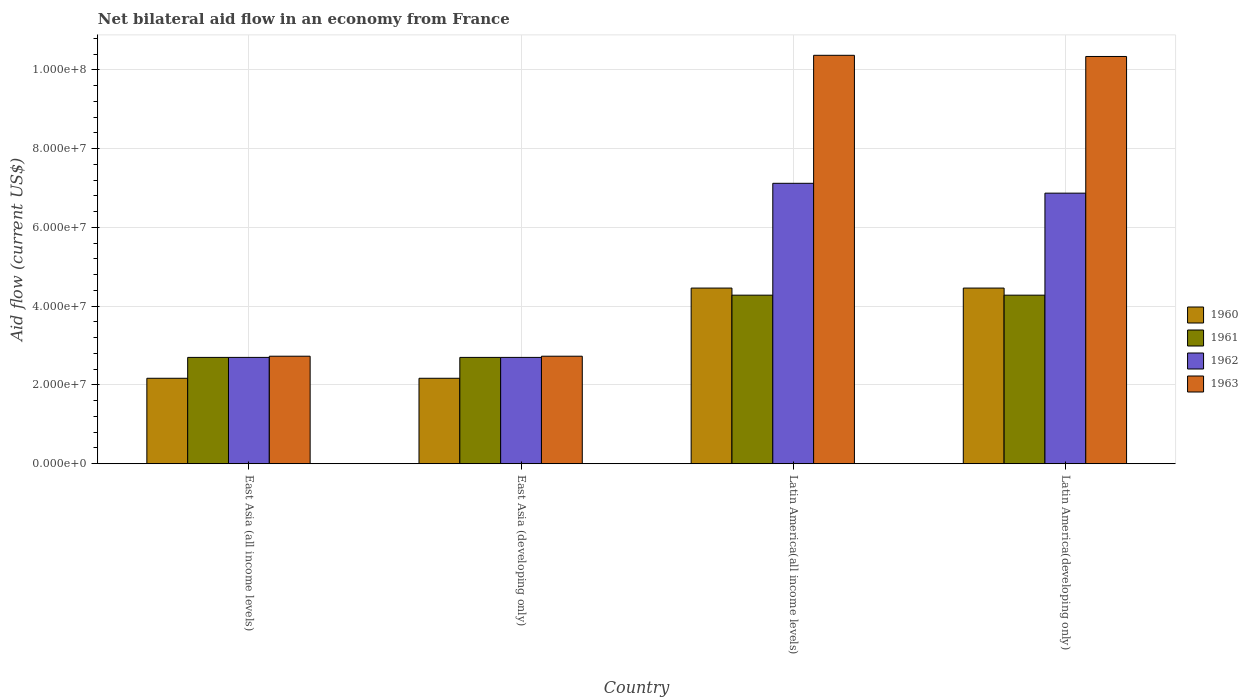Are the number of bars per tick equal to the number of legend labels?
Offer a terse response. Yes. How many bars are there on the 3rd tick from the left?
Your response must be concise. 4. How many bars are there on the 1st tick from the right?
Your response must be concise. 4. What is the label of the 3rd group of bars from the left?
Your answer should be compact. Latin America(all income levels). In how many cases, is the number of bars for a given country not equal to the number of legend labels?
Give a very brief answer. 0. What is the net bilateral aid flow in 1962 in Latin America(developing only)?
Offer a terse response. 6.87e+07. Across all countries, what is the maximum net bilateral aid flow in 1961?
Your answer should be very brief. 4.28e+07. Across all countries, what is the minimum net bilateral aid flow in 1961?
Offer a very short reply. 2.70e+07. In which country was the net bilateral aid flow in 1960 maximum?
Give a very brief answer. Latin America(all income levels). In which country was the net bilateral aid flow in 1963 minimum?
Offer a very short reply. East Asia (all income levels). What is the total net bilateral aid flow in 1962 in the graph?
Keep it short and to the point. 1.94e+08. What is the difference between the net bilateral aid flow in 1960 in East Asia (developing only) and that in Latin America(all income levels)?
Offer a very short reply. -2.29e+07. What is the difference between the net bilateral aid flow in 1963 in Latin America(all income levels) and the net bilateral aid flow in 1960 in Latin America(developing only)?
Offer a terse response. 5.91e+07. What is the average net bilateral aid flow in 1962 per country?
Provide a succinct answer. 4.85e+07. What is the difference between the net bilateral aid flow of/in 1961 and net bilateral aid flow of/in 1960 in Latin America(all income levels)?
Provide a succinct answer. -1.80e+06. What is the ratio of the net bilateral aid flow in 1963 in Latin America(all income levels) to that in Latin America(developing only)?
Your answer should be very brief. 1. What is the difference between the highest and the second highest net bilateral aid flow in 1960?
Your answer should be compact. 2.29e+07. What is the difference between the highest and the lowest net bilateral aid flow in 1963?
Make the answer very short. 7.64e+07. Is it the case that in every country, the sum of the net bilateral aid flow in 1960 and net bilateral aid flow in 1963 is greater than the sum of net bilateral aid flow in 1961 and net bilateral aid flow in 1962?
Make the answer very short. Yes. What does the 4th bar from the right in East Asia (developing only) represents?
Offer a terse response. 1960. Is it the case that in every country, the sum of the net bilateral aid flow in 1962 and net bilateral aid flow in 1960 is greater than the net bilateral aid flow in 1961?
Offer a terse response. Yes. How many bars are there?
Offer a terse response. 16. How many countries are there in the graph?
Your answer should be very brief. 4. Does the graph contain any zero values?
Provide a short and direct response. No. Does the graph contain grids?
Provide a short and direct response. Yes. How many legend labels are there?
Provide a succinct answer. 4. What is the title of the graph?
Your answer should be very brief. Net bilateral aid flow in an economy from France. What is the label or title of the Y-axis?
Ensure brevity in your answer.  Aid flow (current US$). What is the Aid flow (current US$) in 1960 in East Asia (all income levels)?
Your response must be concise. 2.17e+07. What is the Aid flow (current US$) in 1961 in East Asia (all income levels)?
Offer a very short reply. 2.70e+07. What is the Aid flow (current US$) of 1962 in East Asia (all income levels)?
Your answer should be compact. 2.70e+07. What is the Aid flow (current US$) of 1963 in East Asia (all income levels)?
Provide a succinct answer. 2.73e+07. What is the Aid flow (current US$) in 1960 in East Asia (developing only)?
Your answer should be very brief. 2.17e+07. What is the Aid flow (current US$) of 1961 in East Asia (developing only)?
Provide a succinct answer. 2.70e+07. What is the Aid flow (current US$) in 1962 in East Asia (developing only)?
Offer a terse response. 2.70e+07. What is the Aid flow (current US$) in 1963 in East Asia (developing only)?
Your answer should be very brief. 2.73e+07. What is the Aid flow (current US$) in 1960 in Latin America(all income levels)?
Provide a short and direct response. 4.46e+07. What is the Aid flow (current US$) of 1961 in Latin America(all income levels)?
Your response must be concise. 4.28e+07. What is the Aid flow (current US$) in 1962 in Latin America(all income levels)?
Your answer should be compact. 7.12e+07. What is the Aid flow (current US$) in 1963 in Latin America(all income levels)?
Your answer should be very brief. 1.04e+08. What is the Aid flow (current US$) in 1960 in Latin America(developing only)?
Keep it short and to the point. 4.46e+07. What is the Aid flow (current US$) in 1961 in Latin America(developing only)?
Provide a short and direct response. 4.28e+07. What is the Aid flow (current US$) of 1962 in Latin America(developing only)?
Provide a short and direct response. 6.87e+07. What is the Aid flow (current US$) of 1963 in Latin America(developing only)?
Your answer should be compact. 1.03e+08. Across all countries, what is the maximum Aid flow (current US$) in 1960?
Your response must be concise. 4.46e+07. Across all countries, what is the maximum Aid flow (current US$) in 1961?
Your answer should be compact. 4.28e+07. Across all countries, what is the maximum Aid flow (current US$) of 1962?
Give a very brief answer. 7.12e+07. Across all countries, what is the maximum Aid flow (current US$) in 1963?
Give a very brief answer. 1.04e+08. Across all countries, what is the minimum Aid flow (current US$) of 1960?
Provide a succinct answer. 2.17e+07. Across all countries, what is the minimum Aid flow (current US$) in 1961?
Your answer should be very brief. 2.70e+07. Across all countries, what is the minimum Aid flow (current US$) of 1962?
Make the answer very short. 2.70e+07. Across all countries, what is the minimum Aid flow (current US$) of 1963?
Offer a terse response. 2.73e+07. What is the total Aid flow (current US$) of 1960 in the graph?
Keep it short and to the point. 1.33e+08. What is the total Aid flow (current US$) in 1961 in the graph?
Give a very brief answer. 1.40e+08. What is the total Aid flow (current US$) in 1962 in the graph?
Offer a terse response. 1.94e+08. What is the total Aid flow (current US$) of 1963 in the graph?
Offer a terse response. 2.62e+08. What is the difference between the Aid flow (current US$) in 1960 in East Asia (all income levels) and that in East Asia (developing only)?
Your answer should be compact. 0. What is the difference between the Aid flow (current US$) in 1961 in East Asia (all income levels) and that in East Asia (developing only)?
Your response must be concise. 0. What is the difference between the Aid flow (current US$) in 1962 in East Asia (all income levels) and that in East Asia (developing only)?
Make the answer very short. 0. What is the difference between the Aid flow (current US$) of 1963 in East Asia (all income levels) and that in East Asia (developing only)?
Your answer should be very brief. 0. What is the difference between the Aid flow (current US$) in 1960 in East Asia (all income levels) and that in Latin America(all income levels)?
Provide a succinct answer. -2.29e+07. What is the difference between the Aid flow (current US$) of 1961 in East Asia (all income levels) and that in Latin America(all income levels)?
Make the answer very short. -1.58e+07. What is the difference between the Aid flow (current US$) of 1962 in East Asia (all income levels) and that in Latin America(all income levels)?
Offer a very short reply. -4.42e+07. What is the difference between the Aid flow (current US$) in 1963 in East Asia (all income levels) and that in Latin America(all income levels)?
Keep it short and to the point. -7.64e+07. What is the difference between the Aid flow (current US$) of 1960 in East Asia (all income levels) and that in Latin America(developing only)?
Offer a terse response. -2.29e+07. What is the difference between the Aid flow (current US$) of 1961 in East Asia (all income levels) and that in Latin America(developing only)?
Offer a very short reply. -1.58e+07. What is the difference between the Aid flow (current US$) in 1962 in East Asia (all income levels) and that in Latin America(developing only)?
Your answer should be very brief. -4.17e+07. What is the difference between the Aid flow (current US$) in 1963 in East Asia (all income levels) and that in Latin America(developing only)?
Ensure brevity in your answer.  -7.61e+07. What is the difference between the Aid flow (current US$) in 1960 in East Asia (developing only) and that in Latin America(all income levels)?
Offer a very short reply. -2.29e+07. What is the difference between the Aid flow (current US$) in 1961 in East Asia (developing only) and that in Latin America(all income levels)?
Ensure brevity in your answer.  -1.58e+07. What is the difference between the Aid flow (current US$) in 1962 in East Asia (developing only) and that in Latin America(all income levels)?
Provide a short and direct response. -4.42e+07. What is the difference between the Aid flow (current US$) in 1963 in East Asia (developing only) and that in Latin America(all income levels)?
Offer a very short reply. -7.64e+07. What is the difference between the Aid flow (current US$) in 1960 in East Asia (developing only) and that in Latin America(developing only)?
Offer a very short reply. -2.29e+07. What is the difference between the Aid flow (current US$) in 1961 in East Asia (developing only) and that in Latin America(developing only)?
Ensure brevity in your answer.  -1.58e+07. What is the difference between the Aid flow (current US$) in 1962 in East Asia (developing only) and that in Latin America(developing only)?
Give a very brief answer. -4.17e+07. What is the difference between the Aid flow (current US$) in 1963 in East Asia (developing only) and that in Latin America(developing only)?
Your answer should be compact. -7.61e+07. What is the difference between the Aid flow (current US$) of 1961 in Latin America(all income levels) and that in Latin America(developing only)?
Provide a succinct answer. 0. What is the difference between the Aid flow (current US$) in 1962 in Latin America(all income levels) and that in Latin America(developing only)?
Your answer should be very brief. 2.50e+06. What is the difference between the Aid flow (current US$) in 1963 in Latin America(all income levels) and that in Latin America(developing only)?
Your answer should be very brief. 3.00e+05. What is the difference between the Aid flow (current US$) of 1960 in East Asia (all income levels) and the Aid flow (current US$) of 1961 in East Asia (developing only)?
Your answer should be compact. -5.30e+06. What is the difference between the Aid flow (current US$) in 1960 in East Asia (all income levels) and the Aid flow (current US$) in 1962 in East Asia (developing only)?
Ensure brevity in your answer.  -5.30e+06. What is the difference between the Aid flow (current US$) of 1960 in East Asia (all income levels) and the Aid flow (current US$) of 1963 in East Asia (developing only)?
Offer a terse response. -5.60e+06. What is the difference between the Aid flow (current US$) of 1961 in East Asia (all income levels) and the Aid flow (current US$) of 1963 in East Asia (developing only)?
Your response must be concise. -3.00e+05. What is the difference between the Aid flow (current US$) in 1960 in East Asia (all income levels) and the Aid flow (current US$) in 1961 in Latin America(all income levels)?
Your answer should be very brief. -2.11e+07. What is the difference between the Aid flow (current US$) in 1960 in East Asia (all income levels) and the Aid flow (current US$) in 1962 in Latin America(all income levels)?
Provide a succinct answer. -4.95e+07. What is the difference between the Aid flow (current US$) in 1960 in East Asia (all income levels) and the Aid flow (current US$) in 1963 in Latin America(all income levels)?
Offer a very short reply. -8.20e+07. What is the difference between the Aid flow (current US$) of 1961 in East Asia (all income levels) and the Aid flow (current US$) of 1962 in Latin America(all income levels)?
Offer a terse response. -4.42e+07. What is the difference between the Aid flow (current US$) in 1961 in East Asia (all income levels) and the Aid flow (current US$) in 1963 in Latin America(all income levels)?
Ensure brevity in your answer.  -7.67e+07. What is the difference between the Aid flow (current US$) in 1962 in East Asia (all income levels) and the Aid flow (current US$) in 1963 in Latin America(all income levels)?
Your response must be concise. -7.67e+07. What is the difference between the Aid flow (current US$) in 1960 in East Asia (all income levels) and the Aid flow (current US$) in 1961 in Latin America(developing only)?
Your answer should be compact. -2.11e+07. What is the difference between the Aid flow (current US$) of 1960 in East Asia (all income levels) and the Aid flow (current US$) of 1962 in Latin America(developing only)?
Offer a terse response. -4.70e+07. What is the difference between the Aid flow (current US$) in 1960 in East Asia (all income levels) and the Aid flow (current US$) in 1963 in Latin America(developing only)?
Your answer should be compact. -8.17e+07. What is the difference between the Aid flow (current US$) of 1961 in East Asia (all income levels) and the Aid flow (current US$) of 1962 in Latin America(developing only)?
Offer a very short reply. -4.17e+07. What is the difference between the Aid flow (current US$) in 1961 in East Asia (all income levels) and the Aid flow (current US$) in 1963 in Latin America(developing only)?
Offer a very short reply. -7.64e+07. What is the difference between the Aid flow (current US$) in 1962 in East Asia (all income levels) and the Aid flow (current US$) in 1963 in Latin America(developing only)?
Offer a very short reply. -7.64e+07. What is the difference between the Aid flow (current US$) in 1960 in East Asia (developing only) and the Aid flow (current US$) in 1961 in Latin America(all income levels)?
Your response must be concise. -2.11e+07. What is the difference between the Aid flow (current US$) of 1960 in East Asia (developing only) and the Aid flow (current US$) of 1962 in Latin America(all income levels)?
Offer a very short reply. -4.95e+07. What is the difference between the Aid flow (current US$) in 1960 in East Asia (developing only) and the Aid flow (current US$) in 1963 in Latin America(all income levels)?
Give a very brief answer. -8.20e+07. What is the difference between the Aid flow (current US$) in 1961 in East Asia (developing only) and the Aid flow (current US$) in 1962 in Latin America(all income levels)?
Ensure brevity in your answer.  -4.42e+07. What is the difference between the Aid flow (current US$) of 1961 in East Asia (developing only) and the Aid flow (current US$) of 1963 in Latin America(all income levels)?
Provide a succinct answer. -7.67e+07. What is the difference between the Aid flow (current US$) in 1962 in East Asia (developing only) and the Aid flow (current US$) in 1963 in Latin America(all income levels)?
Keep it short and to the point. -7.67e+07. What is the difference between the Aid flow (current US$) in 1960 in East Asia (developing only) and the Aid flow (current US$) in 1961 in Latin America(developing only)?
Provide a short and direct response. -2.11e+07. What is the difference between the Aid flow (current US$) in 1960 in East Asia (developing only) and the Aid flow (current US$) in 1962 in Latin America(developing only)?
Keep it short and to the point. -4.70e+07. What is the difference between the Aid flow (current US$) of 1960 in East Asia (developing only) and the Aid flow (current US$) of 1963 in Latin America(developing only)?
Give a very brief answer. -8.17e+07. What is the difference between the Aid flow (current US$) in 1961 in East Asia (developing only) and the Aid flow (current US$) in 1962 in Latin America(developing only)?
Give a very brief answer. -4.17e+07. What is the difference between the Aid flow (current US$) in 1961 in East Asia (developing only) and the Aid flow (current US$) in 1963 in Latin America(developing only)?
Your answer should be compact. -7.64e+07. What is the difference between the Aid flow (current US$) in 1962 in East Asia (developing only) and the Aid flow (current US$) in 1963 in Latin America(developing only)?
Ensure brevity in your answer.  -7.64e+07. What is the difference between the Aid flow (current US$) in 1960 in Latin America(all income levels) and the Aid flow (current US$) in 1961 in Latin America(developing only)?
Make the answer very short. 1.80e+06. What is the difference between the Aid flow (current US$) in 1960 in Latin America(all income levels) and the Aid flow (current US$) in 1962 in Latin America(developing only)?
Offer a terse response. -2.41e+07. What is the difference between the Aid flow (current US$) in 1960 in Latin America(all income levels) and the Aid flow (current US$) in 1963 in Latin America(developing only)?
Your response must be concise. -5.88e+07. What is the difference between the Aid flow (current US$) in 1961 in Latin America(all income levels) and the Aid flow (current US$) in 1962 in Latin America(developing only)?
Your answer should be very brief. -2.59e+07. What is the difference between the Aid flow (current US$) in 1961 in Latin America(all income levels) and the Aid flow (current US$) in 1963 in Latin America(developing only)?
Offer a terse response. -6.06e+07. What is the difference between the Aid flow (current US$) of 1962 in Latin America(all income levels) and the Aid flow (current US$) of 1963 in Latin America(developing only)?
Give a very brief answer. -3.22e+07. What is the average Aid flow (current US$) of 1960 per country?
Keep it short and to the point. 3.32e+07. What is the average Aid flow (current US$) of 1961 per country?
Offer a very short reply. 3.49e+07. What is the average Aid flow (current US$) in 1962 per country?
Provide a succinct answer. 4.85e+07. What is the average Aid flow (current US$) of 1963 per country?
Ensure brevity in your answer.  6.54e+07. What is the difference between the Aid flow (current US$) in 1960 and Aid flow (current US$) in 1961 in East Asia (all income levels)?
Offer a terse response. -5.30e+06. What is the difference between the Aid flow (current US$) of 1960 and Aid flow (current US$) of 1962 in East Asia (all income levels)?
Provide a succinct answer. -5.30e+06. What is the difference between the Aid flow (current US$) of 1960 and Aid flow (current US$) of 1963 in East Asia (all income levels)?
Offer a terse response. -5.60e+06. What is the difference between the Aid flow (current US$) in 1961 and Aid flow (current US$) in 1963 in East Asia (all income levels)?
Give a very brief answer. -3.00e+05. What is the difference between the Aid flow (current US$) of 1960 and Aid flow (current US$) of 1961 in East Asia (developing only)?
Ensure brevity in your answer.  -5.30e+06. What is the difference between the Aid flow (current US$) in 1960 and Aid flow (current US$) in 1962 in East Asia (developing only)?
Provide a short and direct response. -5.30e+06. What is the difference between the Aid flow (current US$) of 1960 and Aid flow (current US$) of 1963 in East Asia (developing only)?
Your answer should be very brief. -5.60e+06. What is the difference between the Aid flow (current US$) in 1961 and Aid flow (current US$) in 1962 in East Asia (developing only)?
Give a very brief answer. 0. What is the difference between the Aid flow (current US$) of 1961 and Aid flow (current US$) of 1963 in East Asia (developing only)?
Your answer should be very brief. -3.00e+05. What is the difference between the Aid flow (current US$) in 1960 and Aid flow (current US$) in 1961 in Latin America(all income levels)?
Provide a short and direct response. 1.80e+06. What is the difference between the Aid flow (current US$) of 1960 and Aid flow (current US$) of 1962 in Latin America(all income levels)?
Your response must be concise. -2.66e+07. What is the difference between the Aid flow (current US$) of 1960 and Aid flow (current US$) of 1963 in Latin America(all income levels)?
Your response must be concise. -5.91e+07. What is the difference between the Aid flow (current US$) in 1961 and Aid flow (current US$) in 1962 in Latin America(all income levels)?
Your response must be concise. -2.84e+07. What is the difference between the Aid flow (current US$) of 1961 and Aid flow (current US$) of 1963 in Latin America(all income levels)?
Your answer should be very brief. -6.09e+07. What is the difference between the Aid flow (current US$) of 1962 and Aid flow (current US$) of 1963 in Latin America(all income levels)?
Offer a terse response. -3.25e+07. What is the difference between the Aid flow (current US$) in 1960 and Aid flow (current US$) in 1961 in Latin America(developing only)?
Your answer should be compact. 1.80e+06. What is the difference between the Aid flow (current US$) of 1960 and Aid flow (current US$) of 1962 in Latin America(developing only)?
Offer a very short reply. -2.41e+07. What is the difference between the Aid flow (current US$) of 1960 and Aid flow (current US$) of 1963 in Latin America(developing only)?
Offer a terse response. -5.88e+07. What is the difference between the Aid flow (current US$) in 1961 and Aid flow (current US$) in 1962 in Latin America(developing only)?
Offer a very short reply. -2.59e+07. What is the difference between the Aid flow (current US$) in 1961 and Aid flow (current US$) in 1963 in Latin America(developing only)?
Offer a terse response. -6.06e+07. What is the difference between the Aid flow (current US$) of 1962 and Aid flow (current US$) of 1963 in Latin America(developing only)?
Give a very brief answer. -3.47e+07. What is the ratio of the Aid flow (current US$) of 1960 in East Asia (all income levels) to that in East Asia (developing only)?
Offer a terse response. 1. What is the ratio of the Aid flow (current US$) in 1963 in East Asia (all income levels) to that in East Asia (developing only)?
Your answer should be very brief. 1. What is the ratio of the Aid flow (current US$) in 1960 in East Asia (all income levels) to that in Latin America(all income levels)?
Your response must be concise. 0.49. What is the ratio of the Aid flow (current US$) of 1961 in East Asia (all income levels) to that in Latin America(all income levels)?
Ensure brevity in your answer.  0.63. What is the ratio of the Aid flow (current US$) in 1962 in East Asia (all income levels) to that in Latin America(all income levels)?
Give a very brief answer. 0.38. What is the ratio of the Aid flow (current US$) of 1963 in East Asia (all income levels) to that in Latin America(all income levels)?
Your answer should be very brief. 0.26. What is the ratio of the Aid flow (current US$) in 1960 in East Asia (all income levels) to that in Latin America(developing only)?
Offer a terse response. 0.49. What is the ratio of the Aid flow (current US$) of 1961 in East Asia (all income levels) to that in Latin America(developing only)?
Keep it short and to the point. 0.63. What is the ratio of the Aid flow (current US$) of 1962 in East Asia (all income levels) to that in Latin America(developing only)?
Give a very brief answer. 0.39. What is the ratio of the Aid flow (current US$) of 1963 in East Asia (all income levels) to that in Latin America(developing only)?
Your answer should be compact. 0.26. What is the ratio of the Aid flow (current US$) in 1960 in East Asia (developing only) to that in Latin America(all income levels)?
Your answer should be very brief. 0.49. What is the ratio of the Aid flow (current US$) of 1961 in East Asia (developing only) to that in Latin America(all income levels)?
Make the answer very short. 0.63. What is the ratio of the Aid flow (current US$) of 1962 in East Asia (developing only) to that in Latin America(all income levels)?
Keep it short and to the point. 0.38. What is the ratio of the Aid flow (current US$) in 1963 in East Asia (developing only) to that in Latin America(all income levels)?
Make the answer very short. 0.26. What is the ratio of the Aid flow (current US$) in 1960 in East Asia (developing only) to that in Latin America(developing only)?
Keep it short and to the point. 0.49. What is the ratio of the Aid flow (current US$) in 1961 in East Asia (developing only) to that in Latin America(developing only)?
Provide a succinct answer. 0.63. What is the ratio of the Aid flow (current US$) in 1962 in East Asia (developing only) to that in Latin America(developing only)?
Offer a terse response. 0.39. What is the ratio of the Aid flow (current US$) of 1963 in East Asia (developing only) to that in Latin America(developing only)?
Offer a very short reply. 0.26. What is the ratio of the Aid flow (current US$) in 1961 in Latin America(all income levels) to that in Latin America(developing only)?
Offer a very short reply. 1. What is the ratio of the Aid flow (current US$) of 1962 in Latin America(all income levels) to that in Latin America(developing only)?
Make the answer very short. 1.04. What is the ratio of the Aid flow (current US$) of 1963 in Latin America(all income levels) to that in Latin America(developing only)?
Offer a terse response. 1. What is the difference between the highest and the second highest Aid flow (current US$) in 1960?
Provide a succinct answer. 0. What is the difference between the highest and the second highest Aid flow (current US$) of 1961?
Your response must be concise. 0. What is the difference between the highest and the second highest Aid flow (current US$) in 1962?
Offer a terse response. 2.50e+06. What is the difference between the highest and the second highest Aid flow (current US$) of 1963?
Keep it short and to the point. 3.00e+05. What is the difference between the highest and the lowest Aid flow (current US$) in 1960?
Offer a terse response. 2.29e+07. What is the difference between the highest and the lowest Aid flow (current US$) in 1961?
Your answer should be very brief. 1.58e+07. What is the difference between the highest and the lowest Aid flow (current US$) of 1962?
Keep it short and to the point. 4.42e+07. What is the difference between the highest and the lowest Aid flow (current US$) of 1963?
Make the answer very short. 7.64e+07. 